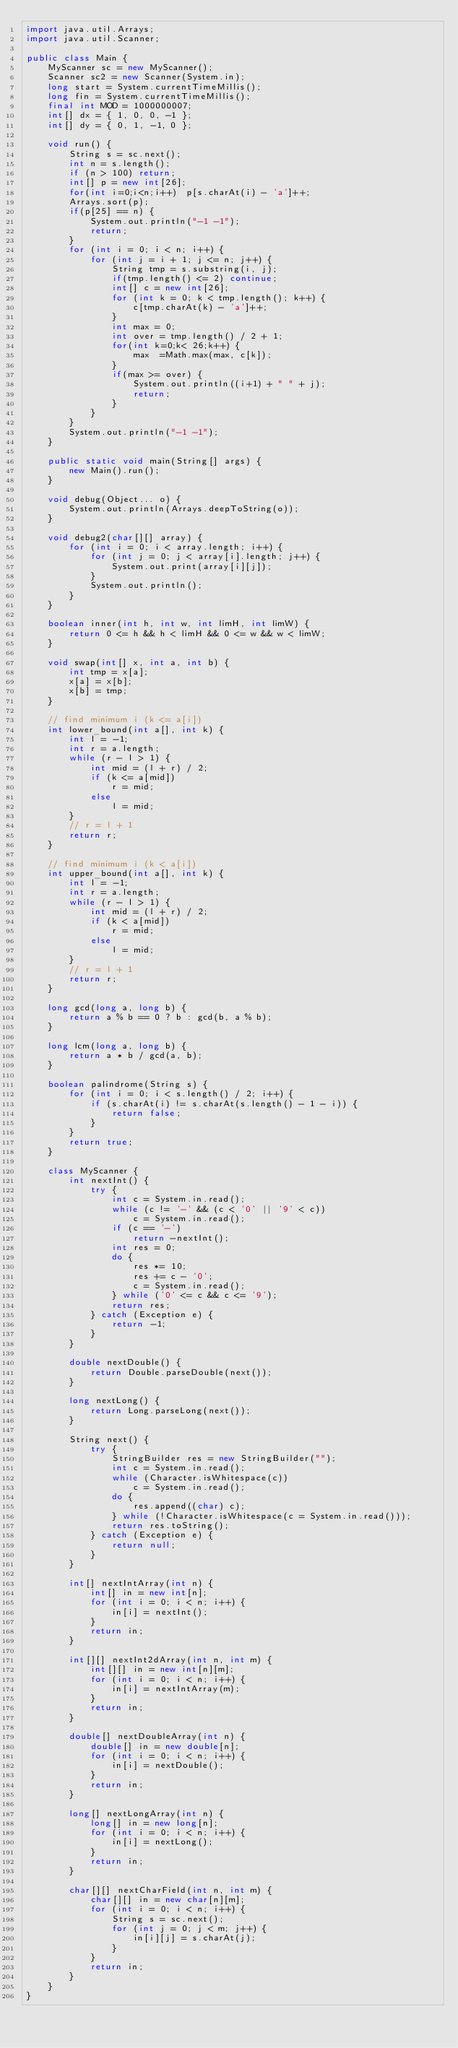Convert code to text. <code><loc_0><loc_0><loc_500><loc_500><_Java_>import java.util.Arrays;
import java.util.Scanner;

public class Main {
	MyScanner sc = new MyScanner();
	Scanner sc2 = new Scanner(System.in);
	long start = System.currentTimeMillis();
	long fin = System.currentTimeMillis();
	final int MOD = 1000000007;
	int[] dx = { 1, 0, 0, -1 };
	int[] dy = { 0, 1, -1, 0 };

	void run() {
		String s = sc.next();
		int n = s.length();
		if (n > 100) return;
		int[] p = new int[26];
		for(int i=0;i<n;i++)  p[s.charAt(i) - 'a']++;
		Arrays.sort(p);
		if(p[25] == n) {
			System.out.println("-1 -1");
			return;
		}
		for (int i = 0; i < n; i++) {
			for (int j = i + 1; j <= n; j++) {
				String tmp = s.substring(i, j);
				if(tmp.length() <= 2) continue;
				int[] c = new int[26];
				for (int k = 0; k < tmp.length(); k++) {
					c[tmp.charAt(k) - 'a']++;
				}
				int max = 0;
				int over = tmp.length() / 2 + 1;
				for(int k=0;k< 26;k++) {
					max  =Math.max(max, c[k]);
				}
				if(max >= over) {
					System.out.println((i+1) + " " + j);
					return;
				}
			}
		}
		System.out.println("-1 -1");
	}

	public static void main(String[] args) {
		new Main().run();
	}

	void debug(Object... o) {
		System.out.println(Arrays.deepToString(o));
	}

	void debug2(char[][] array) {
		for (int i = 0; i < array.length; i++) {
			for (int j = 0; j < array[i].length; j++) {
				System.out.print(array[i][j]);
			}
			System.out.println();
		}
	}

	boolean inner(int h, int w, int limH, int limW) {
		return 0 <= h && h < limH && 0 <= w && w < limW;
	}

	void swap(int[] x, int a, int b) {
		int tmp = x[a];
		x[a] = x[b];
		x[b] = tmp;
	}

	// find minimum i (k <= a[i])
	int lower_bound(int a[], int k) {
		int l = -1;
		int r = a.length;
		while (r - l > 1) {
			int mid = (l + r) / 2;
			if (k <= a[mid])
				r = mid;
			else
				l = mid;
		}
		// r = l + 1
		return r;
	}

	// find minimum i (k < a[i])
	int upper_bound(int a[], int k) {
		int l = -1;
		int r = a.length;
		while (r - l > 1) {
			int mid = (l + r) / 2;
			if (k < a[mid])
				r = mid;
			else
				l = mid;
		}
		// r = l + 1
		return r;
	}

	long gcd(long a, long b) {
		return a % b == 0 ? b : gcd(b, a % b);
	}

	long lcm(long a, long b) {
		return a * b / gcd(a, b);
	}

	boolean palindrome(String s) {
		for (int i = 0; i < s.length() / 2; i++) {
			if (s.charAt(i) != s.charAt(s.length() - 1 - i)) {
				return false;
			}
		}
		return true;
	}

	class MyScanner {
		int nextInt() {
			try {
				int c = System.in.read();
				while (c != '-' && (c < '0' || '9' < c))
					c = System.in.read();
				if (c == '-')
					return -nextInt();
				int res = 0;
				do {
					res *= 10;
					res += c - '0';
					c = System.in.read();
				} while ('0' <= c && c <= '9');
				return res;
			} catch (Exception e) {
				return -1;
			}
		}

		double nextDouble() {
			return Double.parseDouble(next());
		}

		long nextLong() {
			return Long.parseLong(next());
		}

		String next() {
			try {
				StringBuilder res = new StringBuilder("");
				int c = System.in.read();
				while (Character.isWhitespace(c))
					c = System.in.read();
				do {
					res.append((char) c);
				} while (!Character.isWhitespace(c = System.in.read()));
				return res.toString();
			} catch (Exception e) {
				return null;
			}
		}

		int[] nextIntArray(int n) {
			int[] in = new int[n];
			for (int i = 0; i < n; i++) {
				in[i] = nextInt();
			}
			return in;
		}

		int[][] nextInt2dArray(int n, int m) {
			int[][] in = new int[n][m];
			for (int i = 0; i < n; i++) {
				in[i] = nextIntArray(m);
			}
			return in;
		}

		double[] nextDoubleArray(int n) {
			double[] in = new double[n];
			for (int i = 0; i < n; i++) {
				in[i] = nextDouble();
			}
			return in;
		}

		long[] nextLongArray(int n) {
			long[] in = new long[n];
			for (int i = 0; i < n; i++) {
				in[i] = nextLong();
			}
			return in;
		}

		char[][] nextCharField(int n, int m) {
			char[][] in = new char[n][m];
			for (int i = 0; i < n; i++) {
				String s = sc.next();
				for (int j = 0; j < m; j++) {
					in[i][j] = s.charAt(j);
				}
			}
			return in;
		}
	}
}</code> 